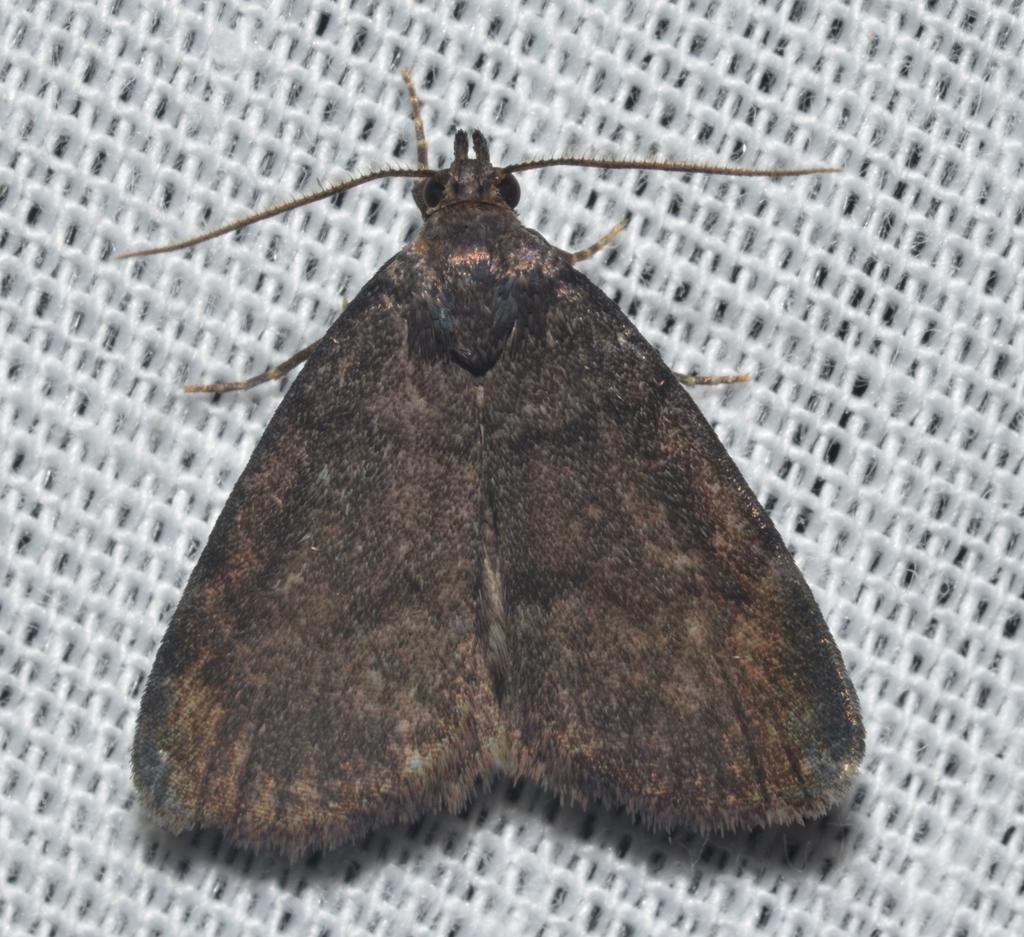What type of insect is in the image? There is a house moth in the image. Where is the house moth located? The house moth is on a path. What breed of dogs can be seen playing with a piece of art in the image? There are no dogs or pieces of art present in the image; it features a house moth on a path. What is the taste of the house moth in the image? The taste of the house moth cannot be determined from the image, as insects do not have a taste that can be perceived by humans. 